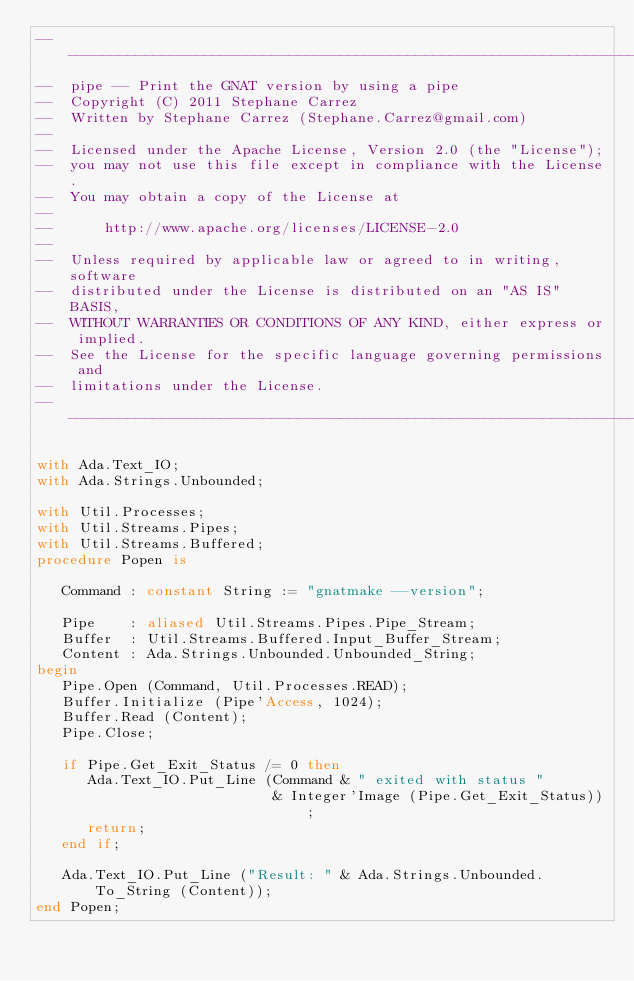Convert code to text. <code><loc_0><loc_0><loc_500><loc_500><_Ada_>-----------------------------------------------------------------------
--  pipe -- Print the GNAT version by using a pipe
--  Copyright (C) 2011 Stephane Carrez
--  Written by Stephane Carrez (Stephane.Carrez@gmail.com)
--
--  Licensed under the Apache License, Version 2.0 (the "License");
--  you may not use this file except in compliance with the License.
--  You may obtain a copy of the License at
--
--      http://www.apache.org/licenses/LICENSE-2.0
--
--  Unless required by applicable law or agreed to in writing, software
--  distributed under the License is distributed on an "AS IS" BASIS,
--  WITHOUT WARRANTIES OR CONDITIONS OF ANY KIND, either express or implied.
--  See the License for the specific language governing permissions and
--  limitations under the License.
-----------------------------------------------------------------------

with Ada.Text_IO;
with Ada.Strings.Unbounded;

with Util.Processes;
with Util.Streams.Pipes;
with Util.Streams.Buffered;
procedure Popen is

   Command : constant String := "gnatmake --version";

   Pipe    : aliased Util.Streams.Pipes.Pipe_Stream;
   Buffer  : Util.Streams.Buffered.Input_Buffer_Stream;
   Content : Ada.Strings.Unbounded.Unbounded_String;
begin
   Pipe.Open (Command, Util.Processes.READ);
   Buffer.Initialize (Pipe'Access, 1024);
   Buffer.Read (Content);
   Pipe.Close;

   if Pipe.Get_Exit_Status /= 0 then
      Ada.Text_IO.Put_Line (Command & " exited with status "
                            & Integer'Image (Pipe.Get_Exit_Status));
      return;
   end if;

   Ada.Text_IO.Put_Line ("Result: " & Ada.Strings.Unbounded.To_String (Content));
end Popen;
</code> 